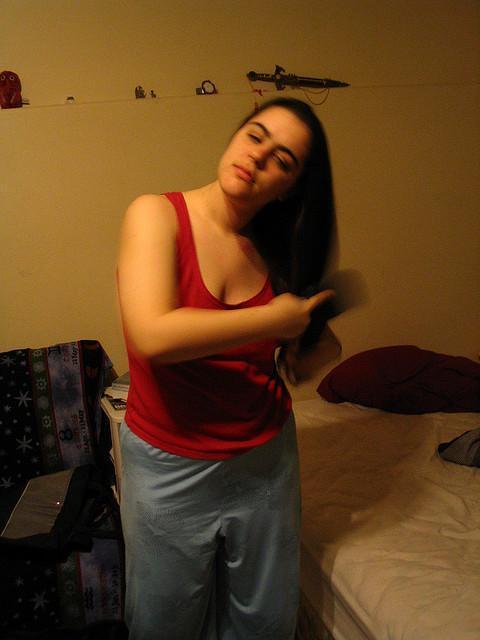How many people are shown?
Give a very brief answer. 1. How many people in the picture?
Give a very brief answer. 1. How many beds are visible?
Give a very brief answer. 1. 